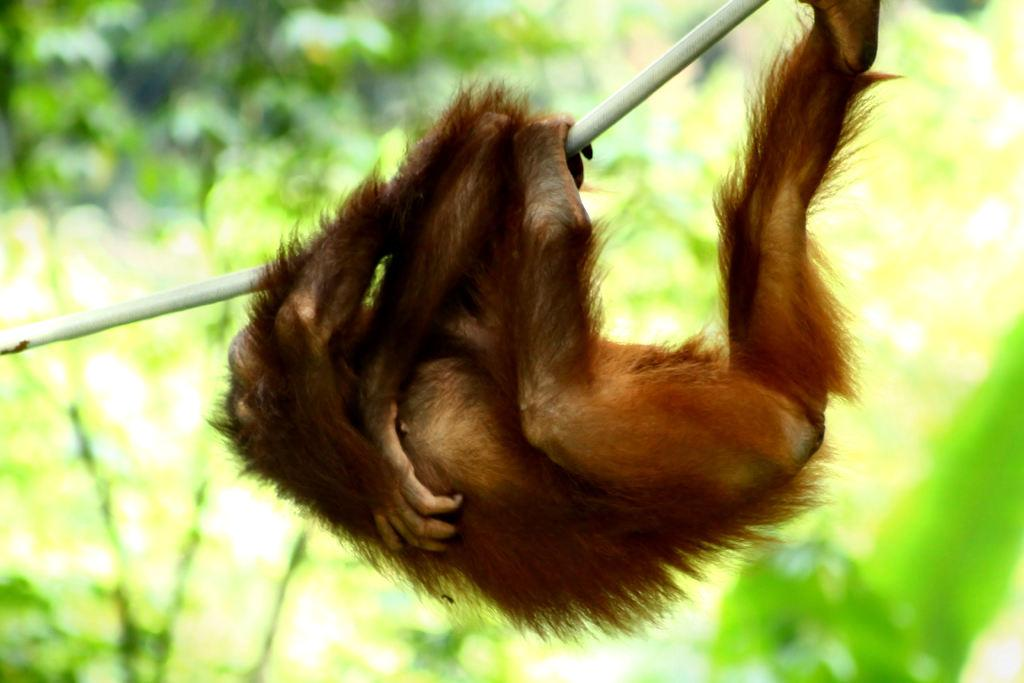What type of animal is in the image? There is a monkey in the image. What else can be seen in the image besides the monkey? There is an object in the image. Can you describe the background of the image? The background of the image is blurred. What type of notebook is the monkey using in the image? There is no notebook present in the image; it only features a monkey and an object. 